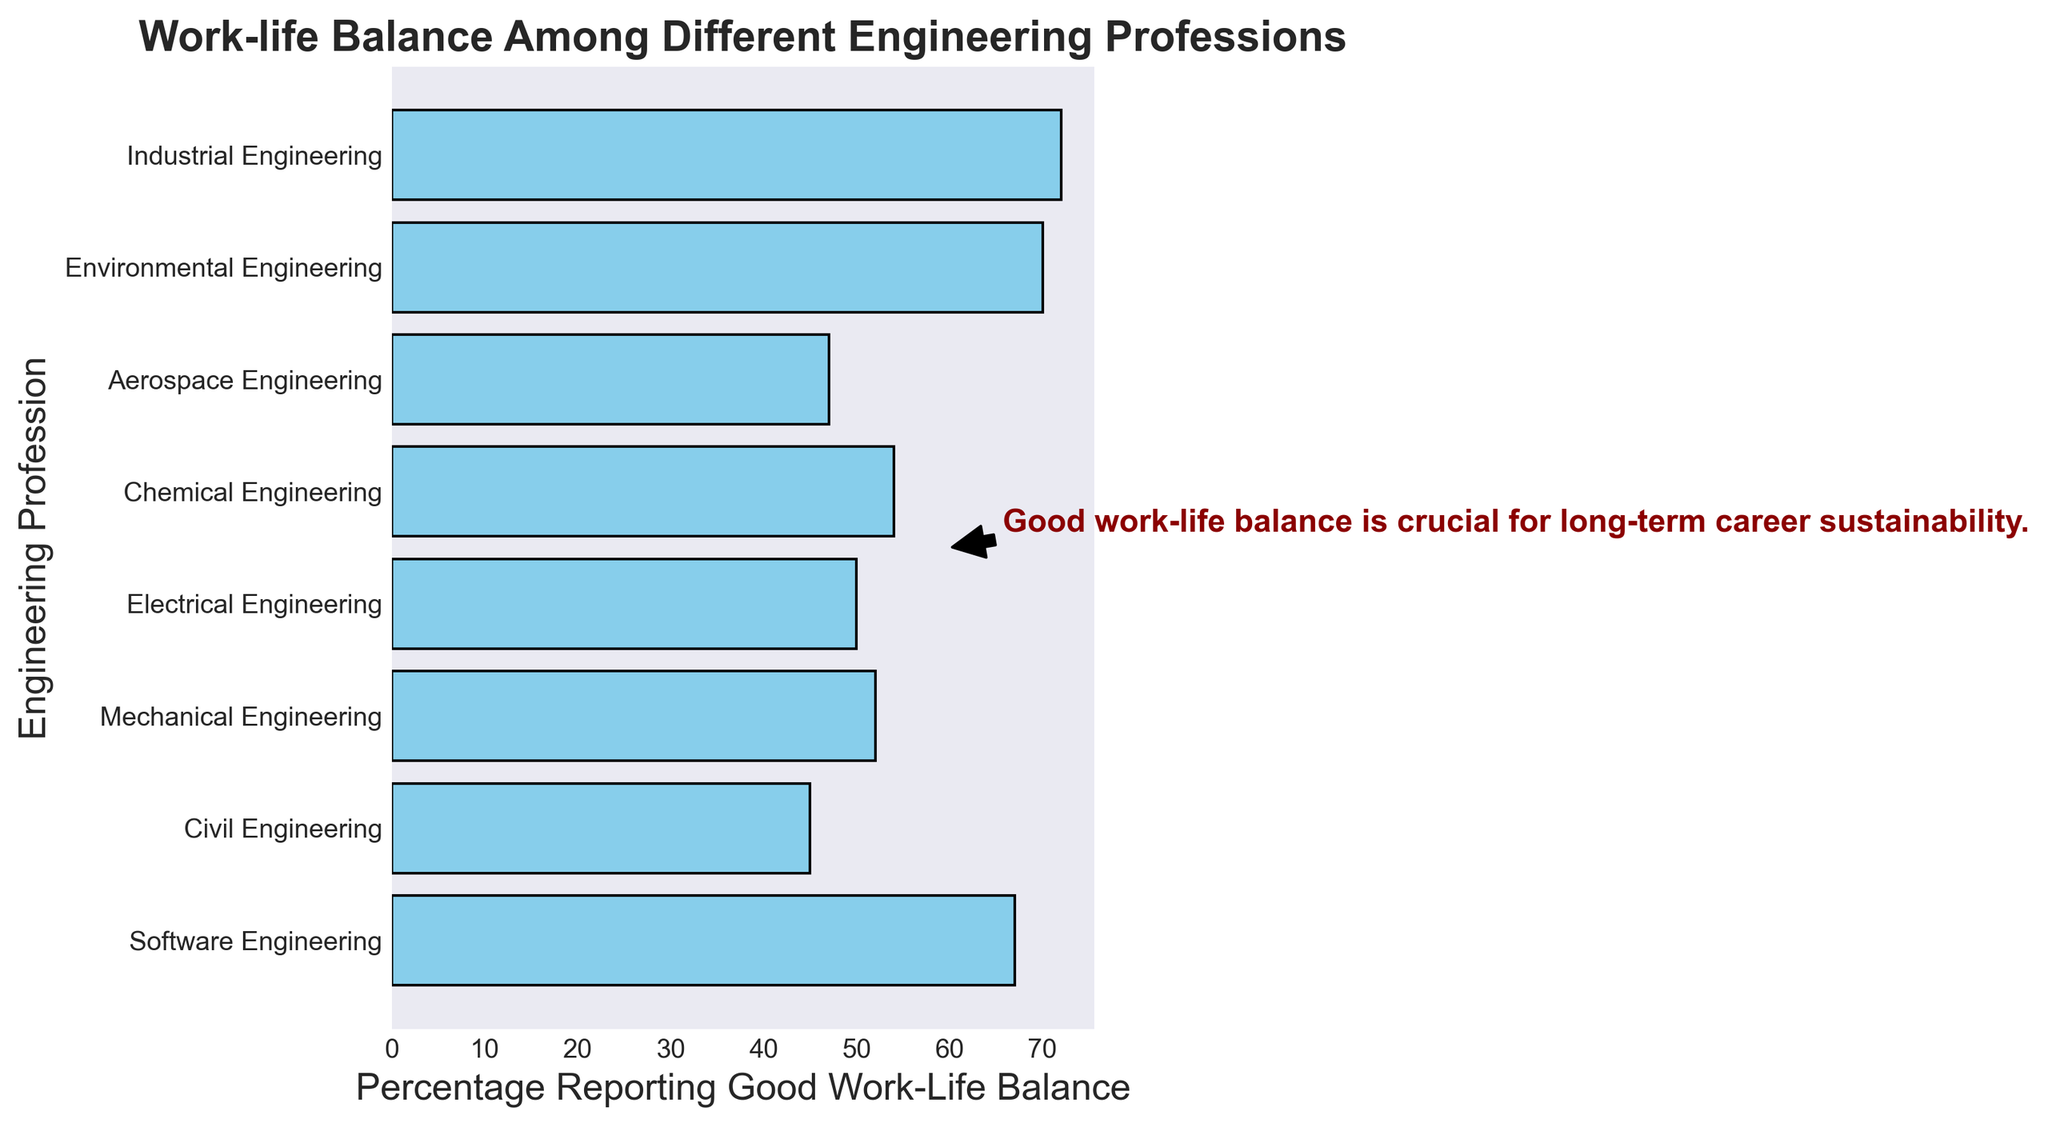Which engineering profession reports the best work-life balance? Look at the bars and find the one with the highest percentage reporting good work-life balance. Industrial Engineering reports 72%.
Answer: Industrial Engineering Which engineering profession reports the worst work-life balance? Look at the bars and find the one with the lowest percentage reporting good work-life balance. Civil Engineering reports 45%.
Answer: Civil Engineering How much higher is the percentage of good work-life balance in Environmental Engineering compared to Aerospace Engineering? Check the percentages for Environmental Engineering (70%) and Aerospace Engineering (47%). Subtract Aerospace from Environmental (70 - 47).
Answer: 23% What is the average percentage of good work-life balance among all the professions? Add the percentages and divide by the number of professions: (67 + 45 + 52 + 50 + 54 + 47 + 70 + 72) / 8 = 57.125.
Answer: 57.125 Which professions have a percentage of good work-life balance above 50%? Identify bars with more than 50%. They are Software, Mechanical, Electrical, Chemical, Environmental, and Industrial Engineering.
Answer: Software, Mechanical, Electrical, Chemical, Environmental, Industrial How many professions have a percentage of good work-life balance below 60%? Count the bars with less than 60%. They are Civil, Mechanical, Electrical, Chemical, and Aerospace Engineering. So, 5 professions.
Answer: 5 What is the difference in percentage points between Software Engineering and Chemical Engineering for good work-life balance? Check the percentages (Software: 67%, Chemical: 54%). Subtract Chemical from Software (67 - 54).
Answer: 13 What is the combined percentage of good work-life balance of the two professions with the lowest balance? Find the percentages for the two lowest: Civil (45%) and Aerospace (47%). Add them together (45 + 47).
Answer: 92 How many professions have a bar that is shorter than 50 percentage points? Count the bars with less than 50%. They are for Civil and Aerospace Engineering, making 2 professions.
Answer: 2 